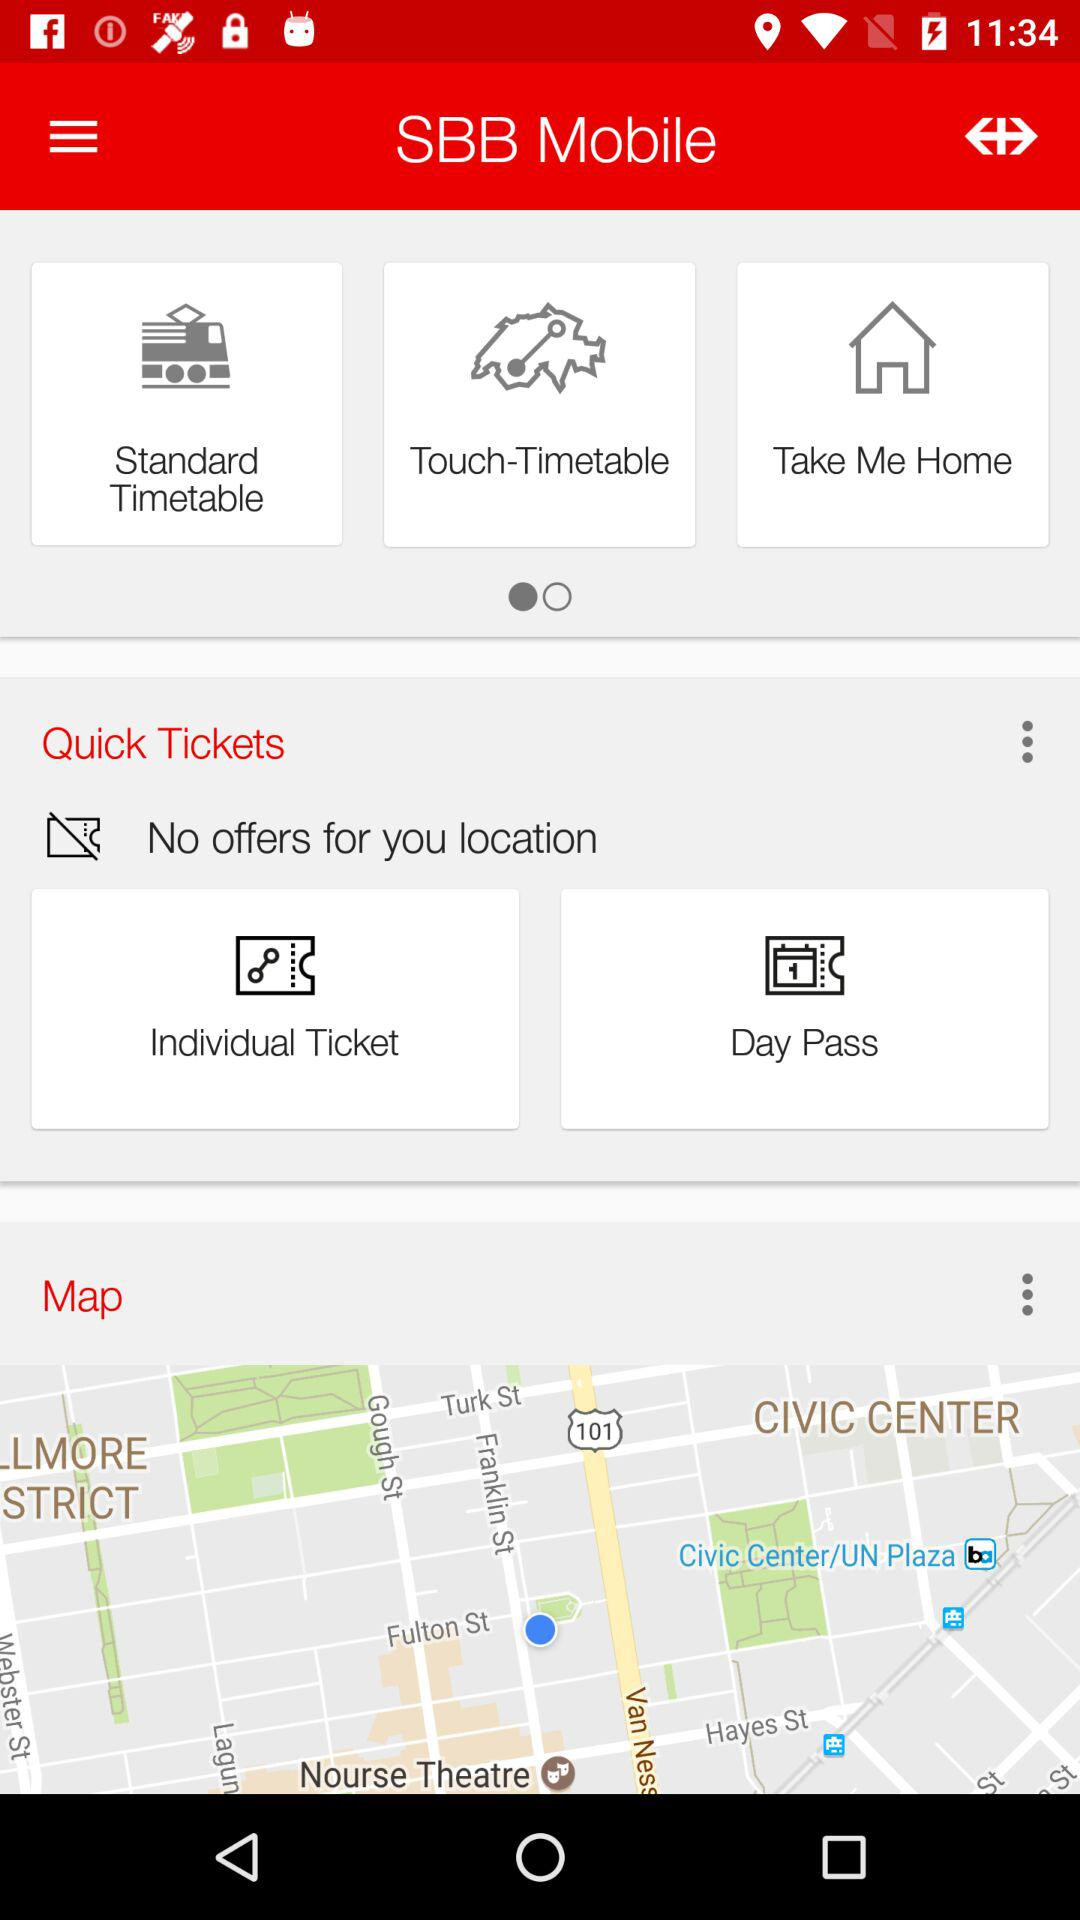What is the application name? The application name is "SBB Mobile". 